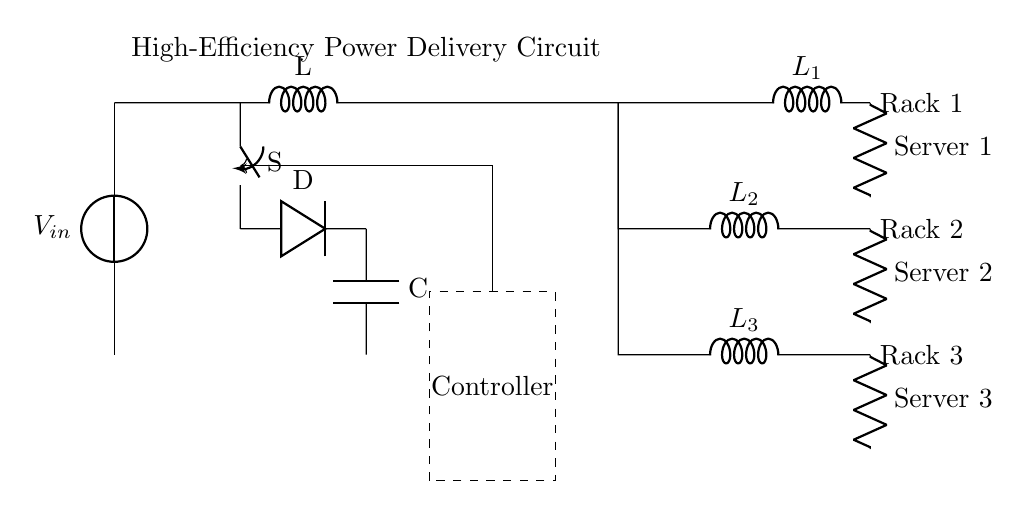What is the input voltage in the circuit? The input voltage is represented by V_in, which is the voltage source at the top of the circuit.
Answer: V_in What type of converter is used in the circuit? The circuit contains a buck converter, which is indicated by the component labeled as S and the diode D connected in the circuit.
Answer: Buck converter How many server loads are connected in this configuration? There are three server loads indicated by the resistors labeled as Server 1, Server 2, and Server 3 at the bottom right section of the circuit.
Answer: Three What is the component labeled L connected to the input from the power source? The component L is an inductor, which is denoted by the symbol 'L' and is situated between the switch and the diode in the circuit.
Answer: Inductor What function does the controller serve in the circuit? The controller, outlined by a dashed rectangle, is used for managing the power distribution to ensure efficient operation of the server racks.
Answer: Managing power distribution What components are part of the power distribution network? The power distribution network includes three inductors labeled as L1, L2, and L3, which are connected to the respective server loads.
Answer: Inductors L1, L2, and L3 Which server load is connected to the lowest position in the circuit? The lowest server load in the circuit is Server 3, indicated by the resistor labeled as Server 3 at the bottom of the circuit diagram.
Answer: Server 3 